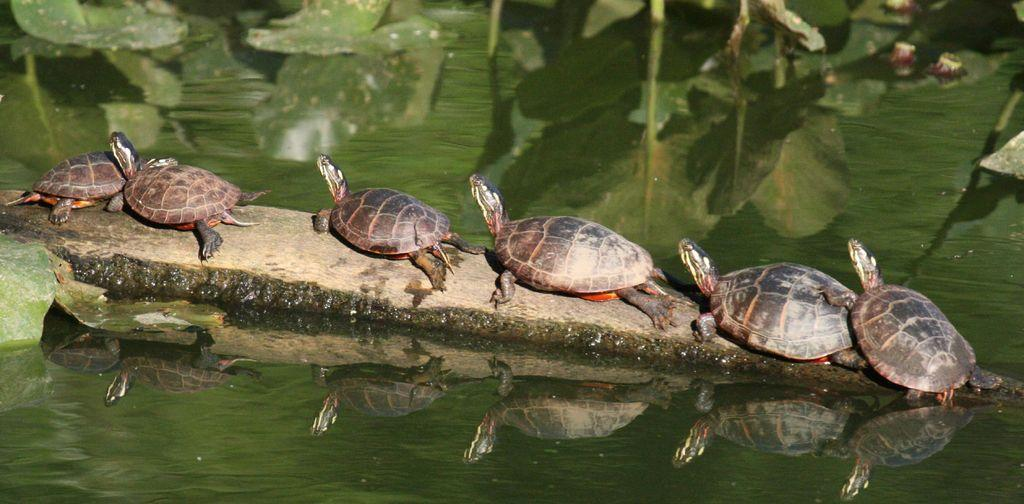What type of animals are present in the image? There are turtles in the image. How are the turtles arranged in the image? The turtles are in a row. What can be seen at the top and bottom of the image? There is water visible at the top and bottom of the image. What type of toys can be seen floating in the water in the image? There are no toys present in the image; it features turtles in a row with water visible at the top and bottom. 